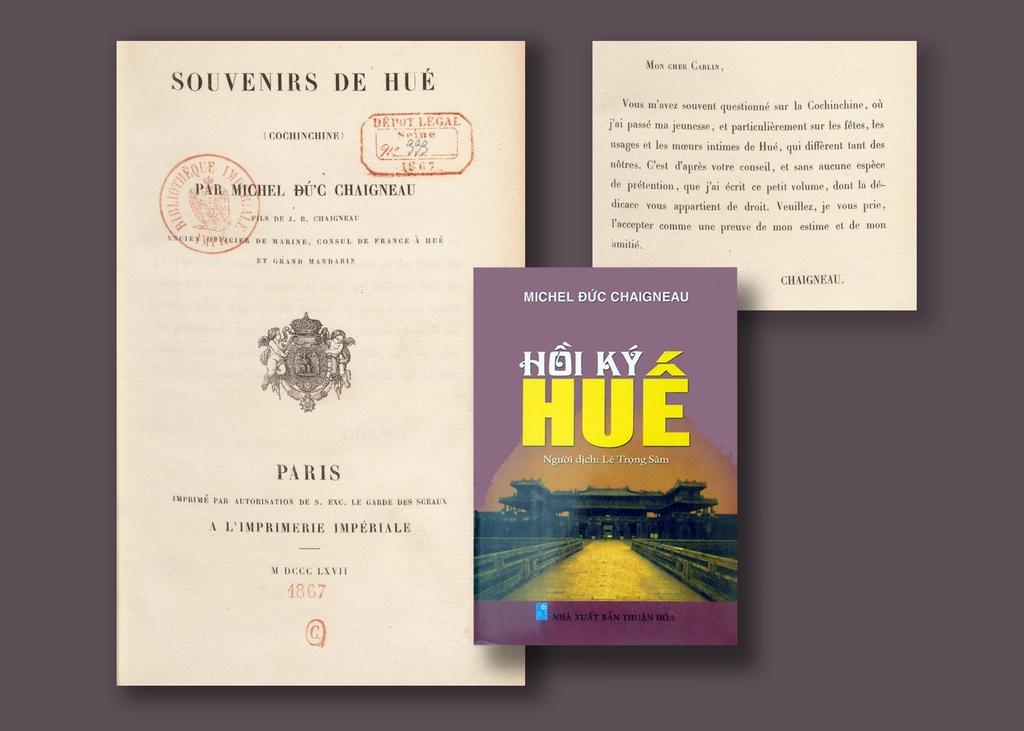What year was the pamphlet on the far left written?
Give a very brief answer. 1867. Who is the author of this book?
Make the answer very short. Michel duc chaigneau. 